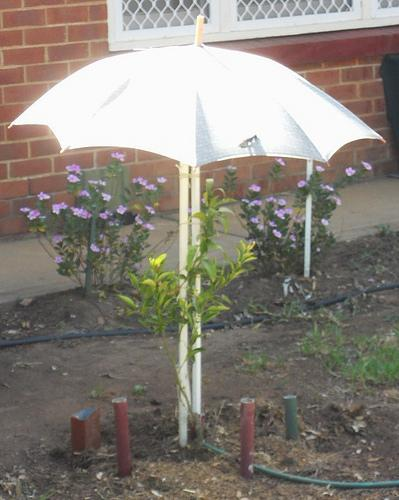Identify three different-sized objects in the scene. A massive white umbrella canopy, a medium-sized green rubber hose, and a small red pole are present in the image. Mention three key elements in the scene and their main attributes. A white umbrella shades a green plant supported by two white stakes, while a black garden hose lies on the ground nearby. Choose one vibrant color in the image and detail three associated items. Purple is dominant in the scene with purple flowers in the background, purple flowers near the plant, and more purple flowers closer to the viewer. Mention an object in the image that has a secondary purpose or use. A green rubber hose is not just a garden decoration, but also serves to water the plant under the umbrella. Pick two objects in the image and describe their relationships. A green rubber hose on the ground can be used to water the green plant under the umbrella. Describe the setting of the image without including any objects. The image is set in a garden with a red brick wall, gray sidewalk, and green grass in the dirt. Imagine you're describing this image to a friend - what stands out most to you? There's a beautiful garden scene with a white umbrella shading a green plant and various purple flowers, and a garden hose nearby. Describe two contrasting objects in the image. A tall white umbrella provides shade for the garden, while a small green plant grows on the ground beneath it. Point out three different materials in the picture. The image has a brick wall, a rubber hose, and a cement sidewalk as part of the scene. Highlight the most significant object in the picture and its characteristics. A large white umbrella in the garden stands out, providing shade to a protected green plant below. 